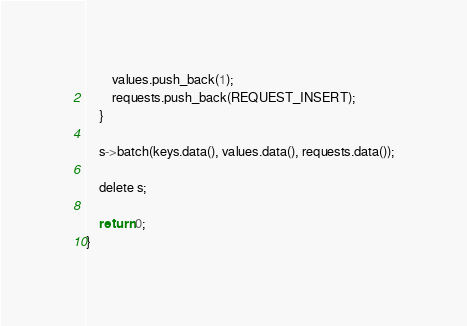<code> <loc_0><loc_0><loc_500><loc_500><_Cuda_>        values.push_back(1);
        requests.push_back(REQUEST_INSERT);
    }

    s->batch(keys.data(), values.data(), requests.data());

    delete s;

    return 0;
}</code> 